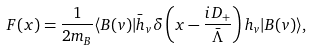<formula> <loc_0><loc_0><loc_500><loc_500>F ( x ) = \frac { 1 } { 2 m _ { B } } \langle B ( v ) | \bar { h } _ { v } \delta \left ( x - \frac { i D _ { + } } { \bar { \Lambda } } \right ) h _ { v } | B ( v ) \rangle ,</formula> 